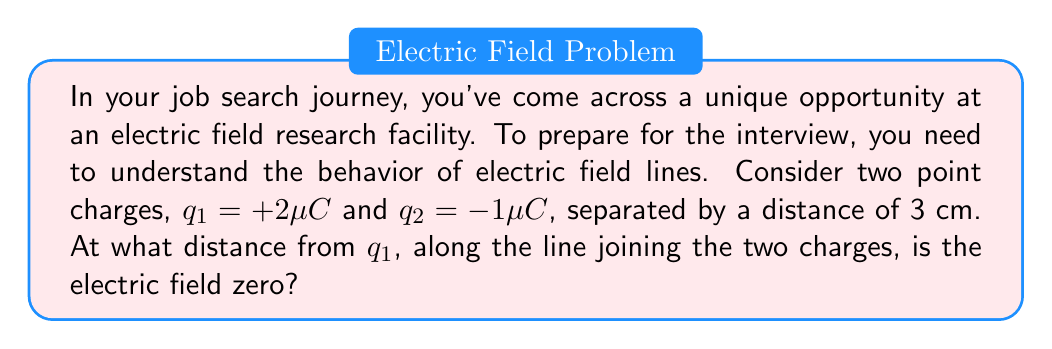Teach me how to tackle this problem. Let's approach this step-by-step:

1) The electric field at any point along the line joining the two charges is the vector sum of the fields due to each charge.

2) Let's define the direction from $q_1$ to $q_2$ as positive. The point where the field is zero will be closer to the weaker charge ($q_2$).

3) Let the distance of this point from $q_1$ be $x$. Then its distance from $q_2$ will be $(3-x)$ cm.

4) At this point, the magnitudes of the fields due to $q_1$ and $q_2$ must be equal:

   $$\frac{kq_1}{x^2} = \frac{kq_2}{(3-x)^2}$$

5) Where $k$ is Coulomb's constant. It cancels out on both sides.

6) Substituting the values:

   $$\frac{2}{x^2} = \frac{1}{(3-x)^2}$$

7) Cross-multiplying:

   $$2(3-x)^2 = x^2$$

8) Expanding:

   $$18 - 12x + 2x^2 = x^2$$

9) Simplifying:

   $$18 - 12x + x^2 = 0$$

10) This is a quadratic equation. Solving it:

    $$x = \frac{12 \pm \sqrt{144 - 4(1)(18)}}{2} = \frac{12 \pm \sqrt{72}}{2} = 6 \pm \sqrt{18}$$

11) We take the positive root as $x$ must be positive:

    $$x = 6 + \sqrt{18} \approx 10.24 \text{ cm}$$
Answer: $10.24 \text{ cm}$ from $q_1$ 